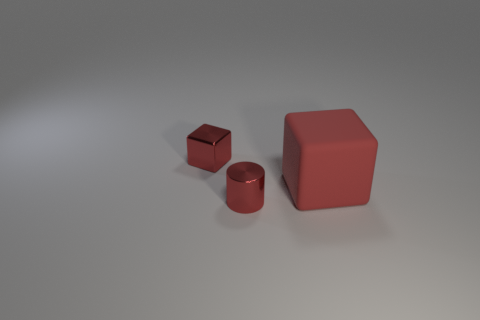Is the size of the matte object the same as the red shiny cylinder?
Your answer should be very brief. No. There is a tiny red metallic thing that is to the right of the tiny object that is behind the tiny cylinder; is there a shiny thing behind it?
Your answer should be very brief. Yes. What is the size of the metallic block?
Keep it short and to the point. Small. How many other cylinders are the same size as the red shiny cylinder?
Make the answer very short. 0. There is another small thing that is the same shape as the rubber thing; what material is it?
Keep it short and to the point. Metal. What shape is the red thing that is behind the red cylinder and to the left of the red matte object?
Ensure brevity in your answer.  Cube. What is the shape of the thing behind the red rubber object?
Your response must be concise. Cube. What number of red things are both to the left of the big object and in front of the tiny cube?
Keep it short and to the point. 1. Does the red rubber object have the same size as the metallic thing that is in front of the large cube?
Offer a terse response. No. There is a red metal object that is in front of the object that is to the right of the red shiny thing that is in front of the large red matte thing; what is its size?
Offer a terse response. Small. 